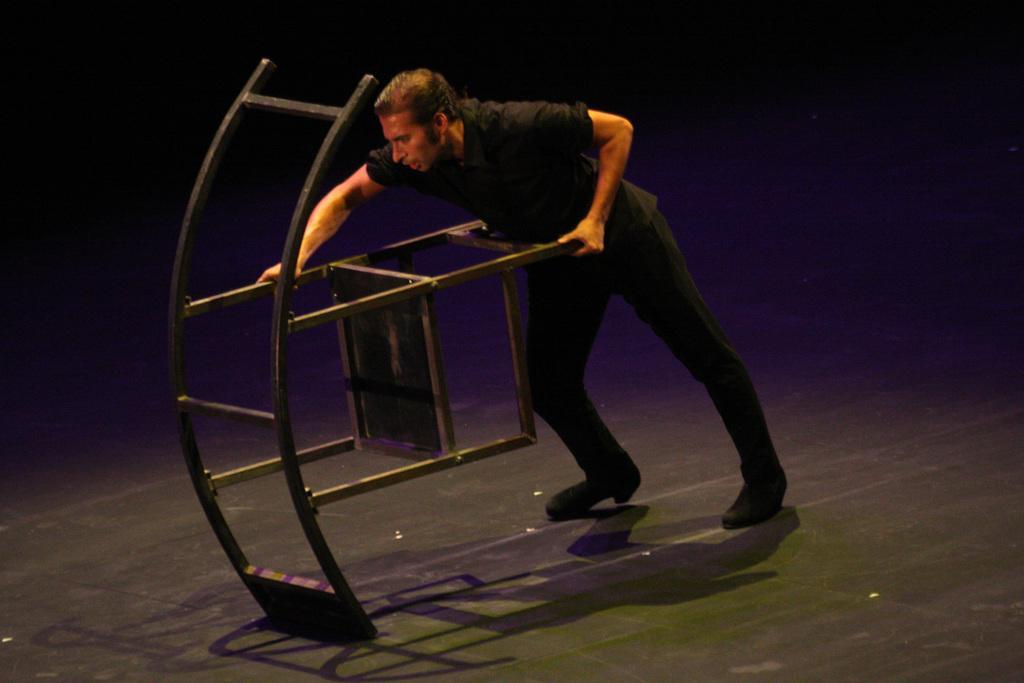In one or two sentences, can you explain what this image depicts? In this image there is a person pushing a metal object on a floor, in the background it is dark. 